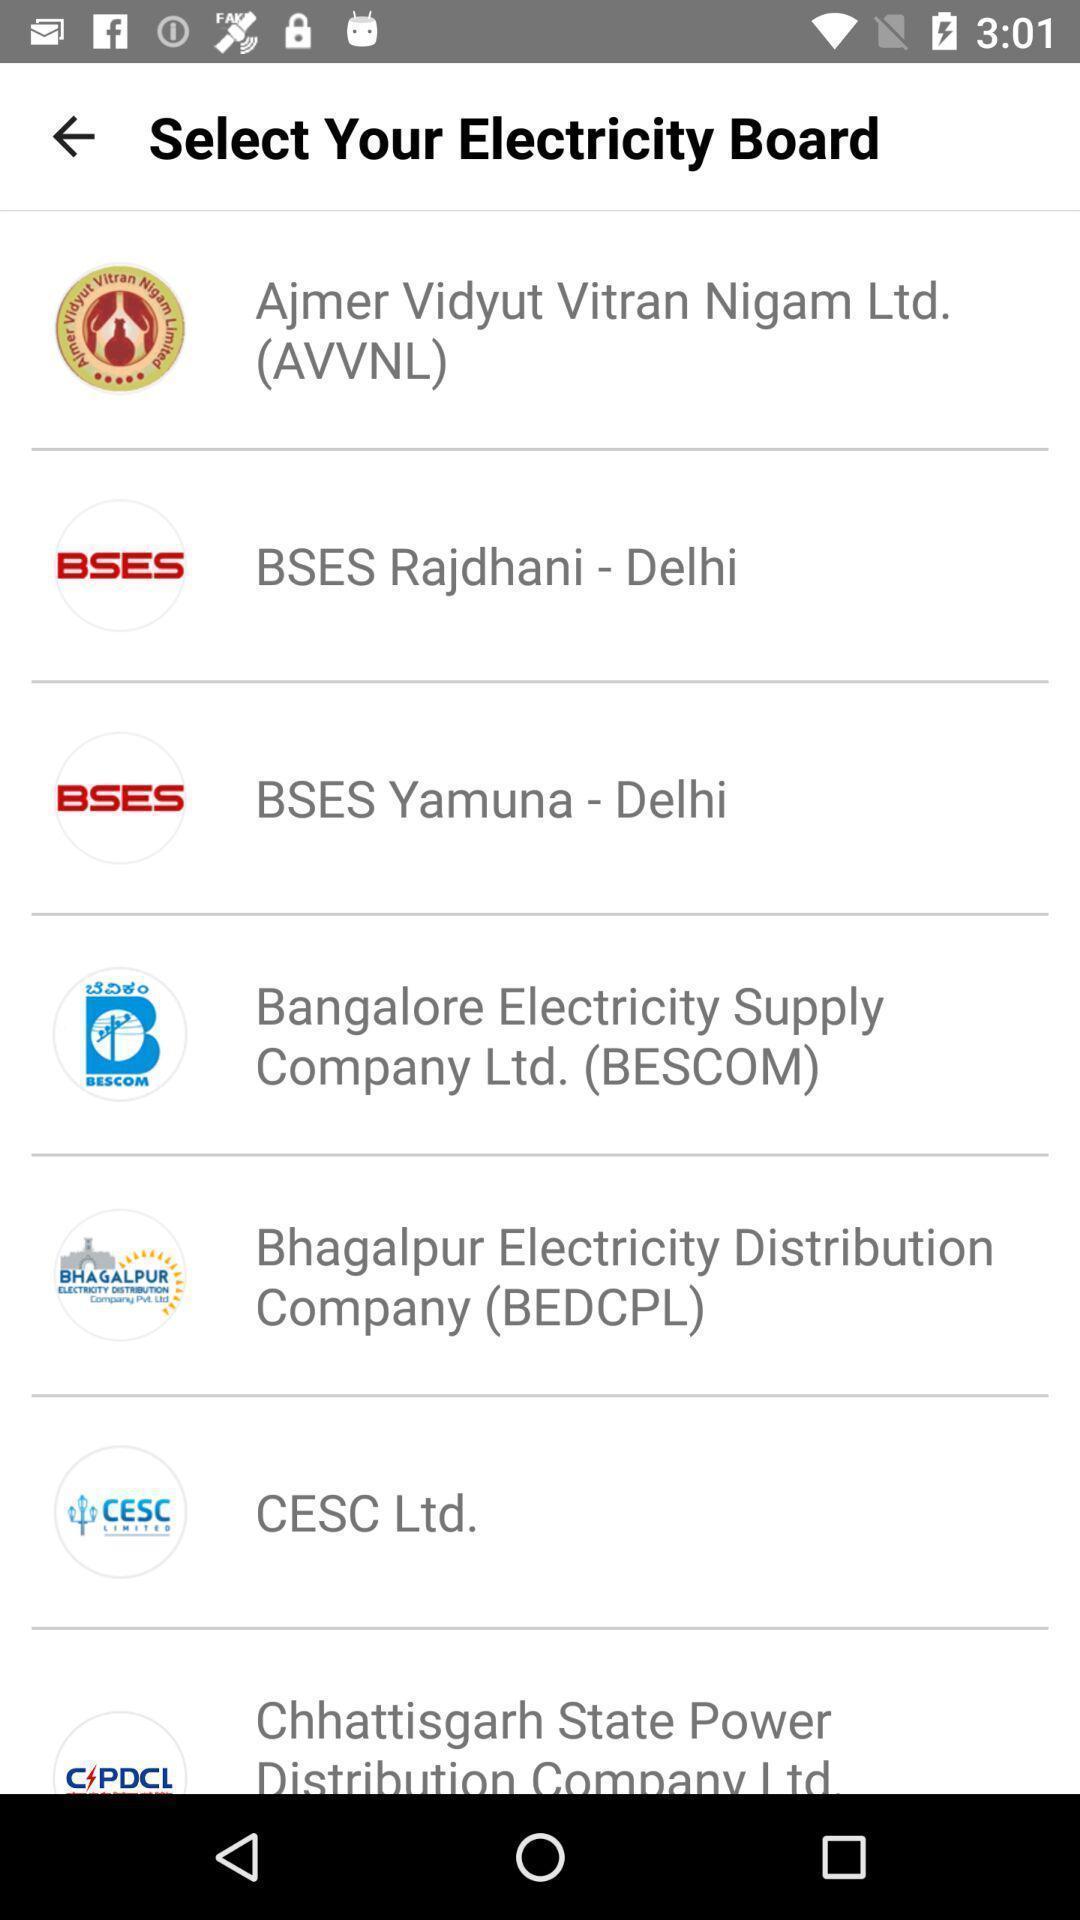What is the overall content of this screenshot? Page to select electricity board. 